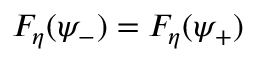<formula> <loc_0><loc_0><loc_500><loc_500>F _ { \eta } ( \psi _ { - } ) = F _ { \eta } ( \psi _ { + } )</formula> 